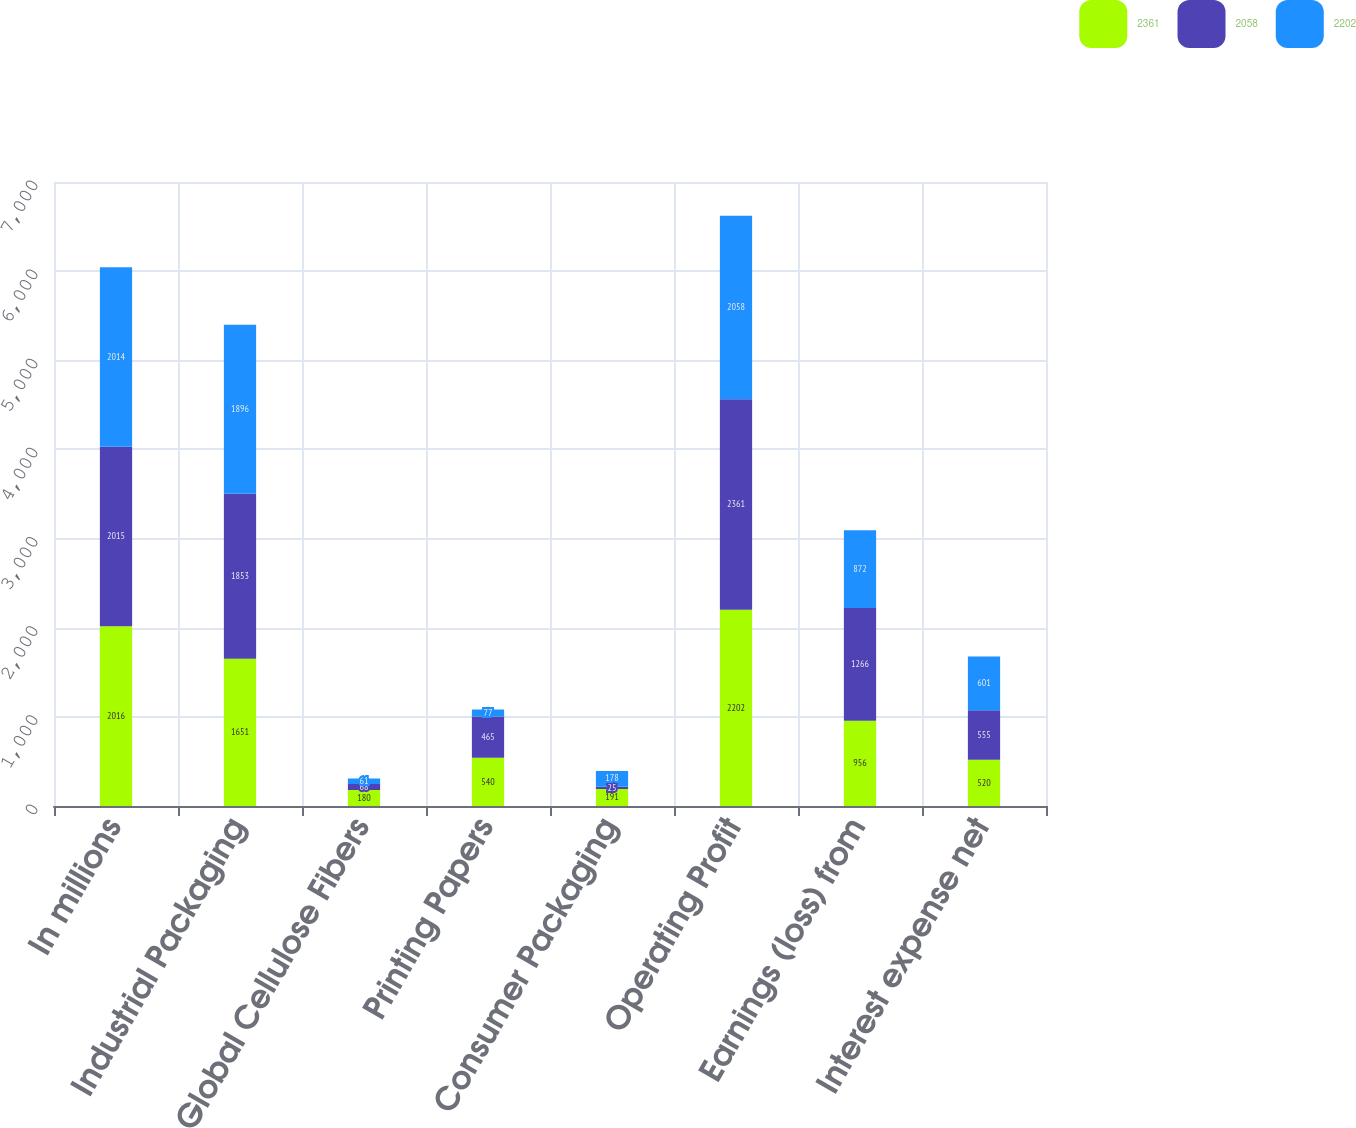Convert chart to OTSL. <chart><loc_0><loc_0><loc_500><loc_500><stacked_bar_chart><ecel><fcel>In millions<fcel>Industrial Packaging<fcel>Global Cellulose Fibers<fcel>Printing Papers<fcel>Consumer Packaging<fcel>Operating Profit<fcel>Earnings (loss) from<fcel>Interest expense net<nl><fcel>2361<fcel>2016<fcel>1651<fcel>180<fcel>540<fcel>191<fcel>2202<fcel>956<fcel>520<nl><fcel>2058<fcel>2015<fcel>1853<fcel>68<fcel>465<fcel>25<fcel>2361<fcel>1266<fcel>555<nl><fcel>2202<fcel>2014<fcel>1896<fcel>61<fcel>77<fcel>178<fcel>2058<fcel>872<fcel>601<nl></chart> 